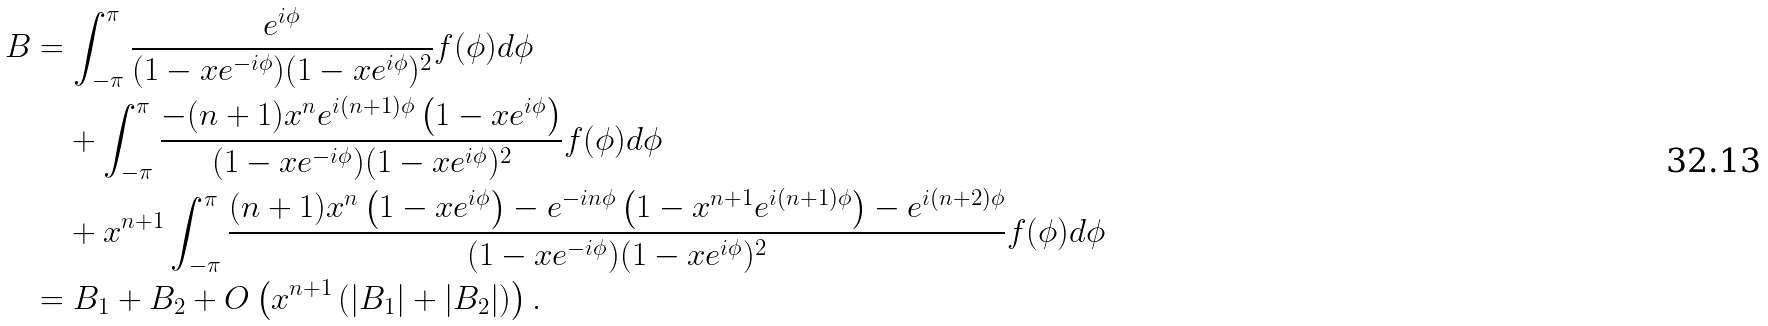<formula> <loc_0><loc_0><loc_500><loc_500>B & = \int _ { - \pi } ^ { \pi } \frac { e ^ { i \phi } } { ( 1 - x e ^ { - i \phi } ) ( 1 - x e ^ { i \phi } ) ^ { 2 } } f ( \phi ) d \phi \\ & \quad + \int _ { - \pi } ^ { \pi } \frac { - ( n + 1 ) x ^ { n } e ^ { i ( n + 1 ) \phi } \left ( 1 - x e ^ { i \phi } \right ) } { ( 1 - x e ^ { - i \phi } ) ( 1 - x e ^ { i \phi } ) ^ { 2 } } f ( \phi ) d \phi \\ & \quad + x ^ { n + 1 } \int _ { - \pi } ^ { \pi } \frac { ( n + 1 ) x ^ { n } \left ( 1 - x e ^ { i \phi } \right ) - e ^ { - i n \phi } \left ( 1 - x ^ { n + 1 } e ^ { i ( n + 1 ) \phi } \right ) - e ^ { i ( n + 2 ) \phi } } { ( 1 - x e ^ { - i \phi } ) ( 1 - x e ^ { i \phi } ) ^ { 2 } } f ( \phi ) d \phi \\ & = B _ { 1 } + B _ { 2 } + O \left ( x ^ { n + 1 } \left ( | B _ { 1 } | + | B _ { 2 } | \right ) \right ) .</formula> 